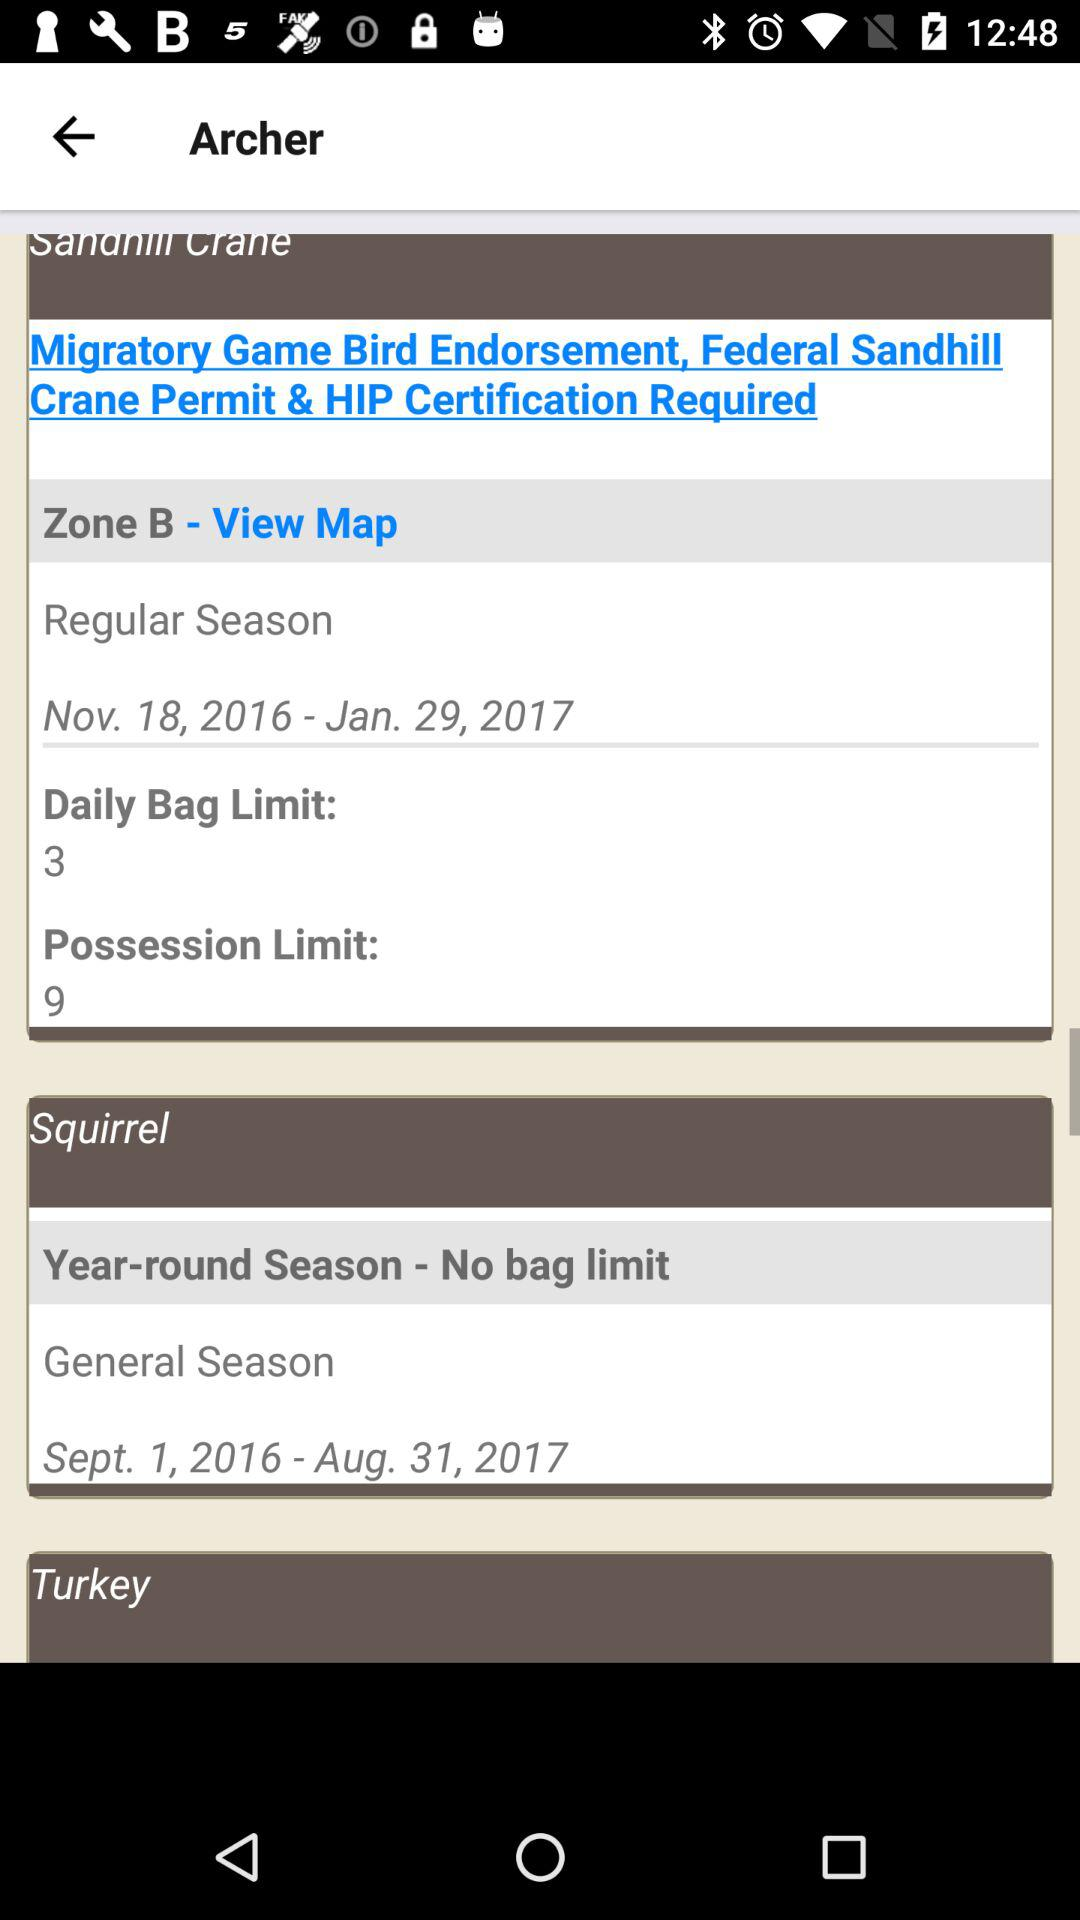What is the date range of the regular season? The date range of the regular season is from November 18, 2016 to January 29, 2017. 